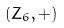<formula> <loc_0><loc_0><loc_500><loc_500>( Z _ { 6 } , + )</formula> 